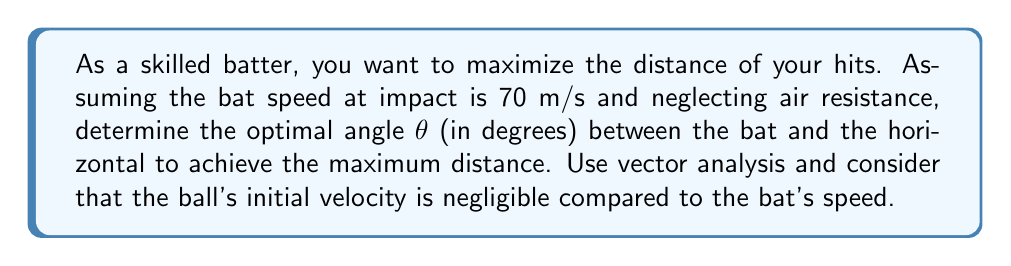Can you solve this math problem? Let's approach this step-by-step using vector analysis:

1) The initial velocity vector of the ball after impact can be represented as:
   $$\vec{v_0} = v_0 \cos\theta \hat{i} + v_0 \sin\theta \hat{j}$$
   where $v_0 = 70$ m/s (bat speed at impact)

2) The equation of motion for a projectile under gravity is:
   $$\vec{r}(t) = (v_0 \cos\theta)t \hat{i} + (v_0 \sin\theta)t - \frac{1}{2}gt^2 \hat{j}$$
   where $g = 9.8$ m/s² (acceleration due to gravity)

3) The time of flight $T$ can be found when $y = 0$ at landing:
   $$0 = (v_0 \sin\theta)T - \frac{1}{2}gT^2$$
   $$T = \frac{2v_0 \sin\theta}{g}$$

4) The horizontal distance $R$ is found by substituting $T$ into the $x$ component:
   $$R = (v_0 \cos\theta)T = \frac{2v_0^2 \sin\theta \cos\theta}{g}$$

5) Using the trigonometric identity $\sin 2\theta = 2\sin\theta \cos\theta$, we get:
   $$R = \frac{v_0^2 \sin 2\theta}{g}$$

6) To maximize $R$, we need to maximize $\sin 2\theta$. This occurs when $2\theta = 90°$ or $\theta = 45°$.

7) Therefore, the optimal angle for maximum distance is 45°.
Answer: 45° 